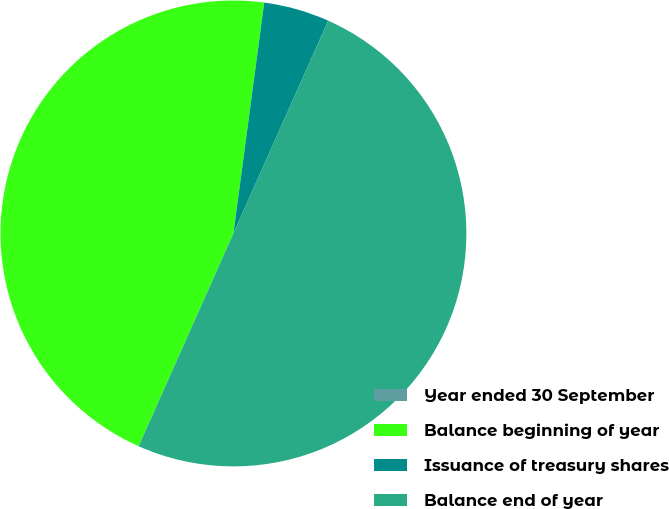Convert chart. <chart><loc_0><loc_0><loc_500><loc_500><pie_chart><fcel>Year ended 30 September<fcel>Balance beginning of year<fcel>Issuance of treasury shares<fcel>Balance end of year<nl><fcel>0.0%<fcel>45.44%<fcel>4.56%<fcel>50.0%<nl></chart> 